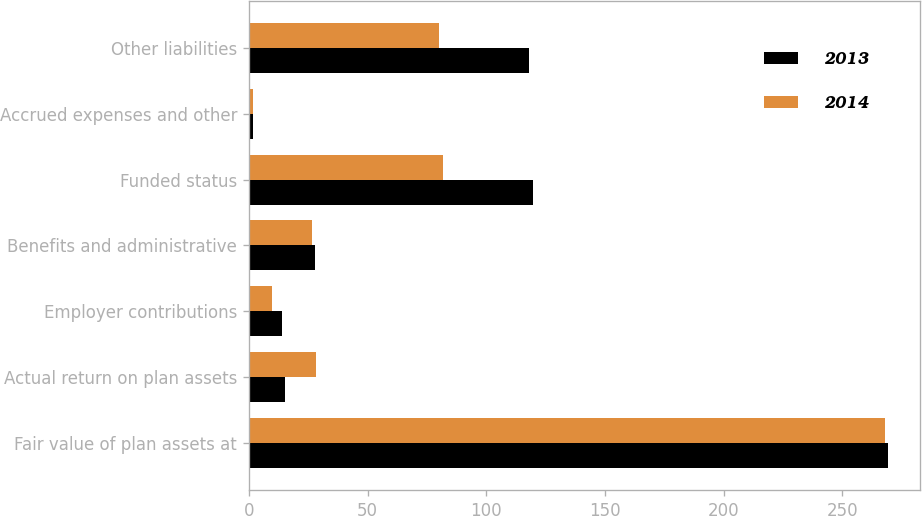Convert chart to OTSL. <chart><loc_0><loc_0><loc_500><loc_500><stacked_bar_chart><ecel><fcel>Fair value of plan assets at<fcel>Actual return on plan assets<fcel>Employer contributions<fcel>Benefits and administrative<fcel>Funded status<fcel>Accrued expenses and other<fcel>Other liabilities<nl><fcel>2013<fcel>269.1<fcel>15.2<fcel>13.8<fcel>28<fcel>119.6<fcel>1.7<fcel>117.9<nl><fcel>2014<fcel>268.1<fcel>28.1<fcel>9.9<fcel>26.7<fcel>81.6<fcel>1.6<fcel>80<nl></chart> 